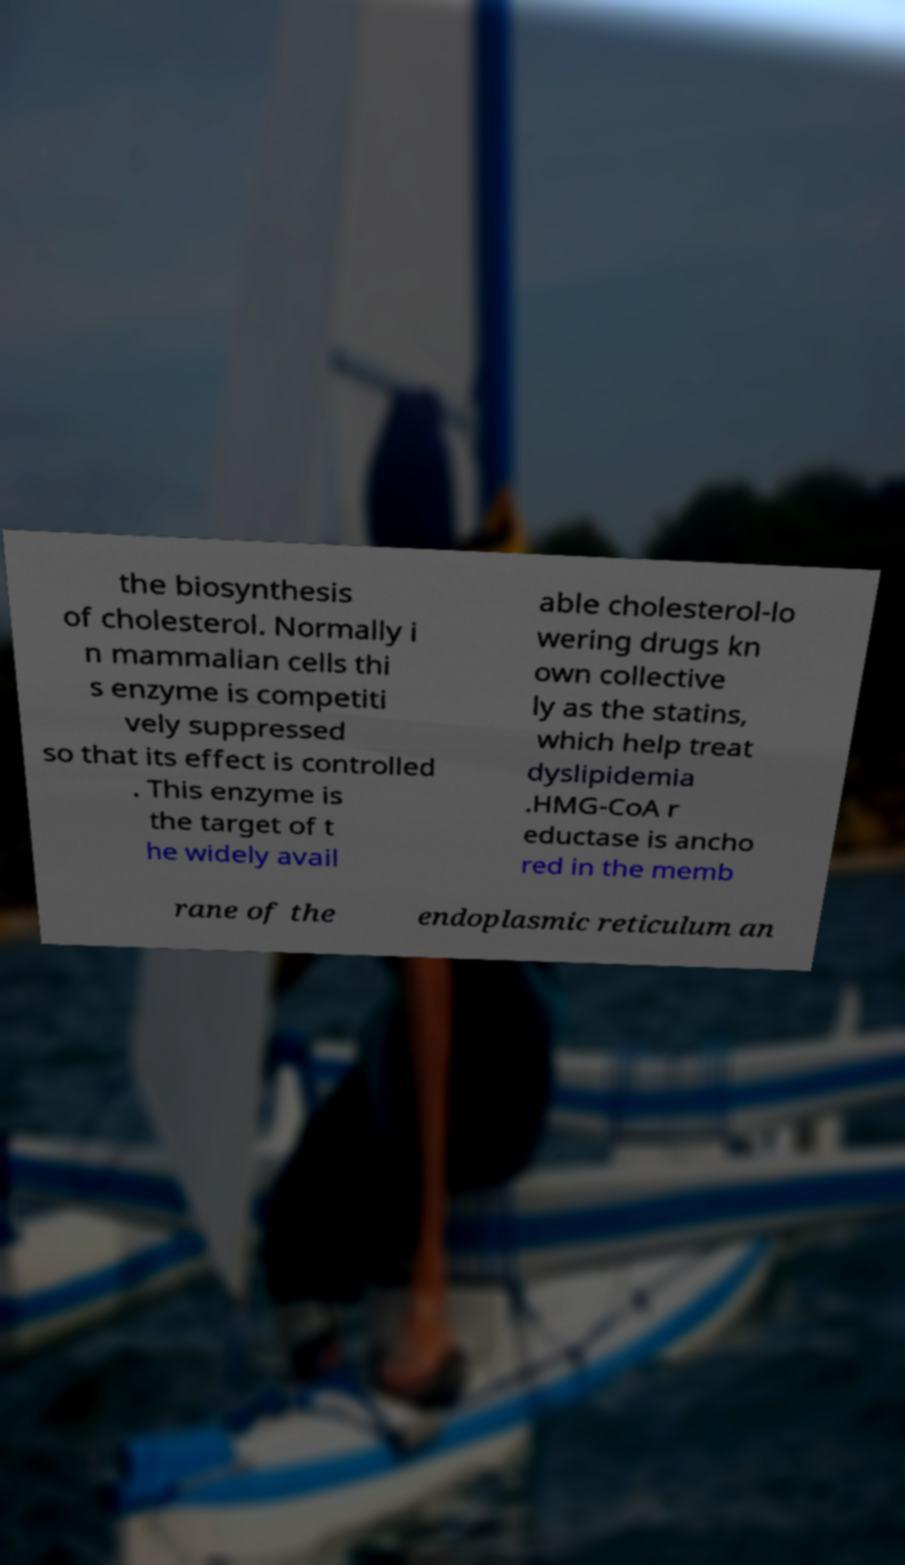For documentation purposes, I need the text within this image transcribed. Could you provide that? the biosynthesis of cholesterol. Normally i n mammalian cells thi s enzyme is competiti vely suppressed so that its effect is controlled . This enzyme is the target of t he widely avail able cholesterol-lo wering drugs kn own collective ly as the statins, which help treat dyslipidemia .HMG-CoA r eductase is ancho red in the memb rane of the endoplasmic reticulum an 